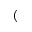<formula> <loc_0><loc_0><loc_500><loc_500>(</formula> 